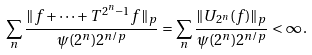<formula> <loc_0><loc_0><loc_500><loc_500>\sum _ { n } \frac { \| f + \dots + T ^ { 2 ^ { n } - 1 } f \| _ { p } } { \psi ( 2 ^ { n } ) 2 ^ { n / p } } = \sum _ { n } \frac { \| U _ { 2 ^ { n } } ( f ) \| _ { p } } { \psi ( 2 ^ { n } ) 2 ^ { n / p } } < \infty \, .</formula> 